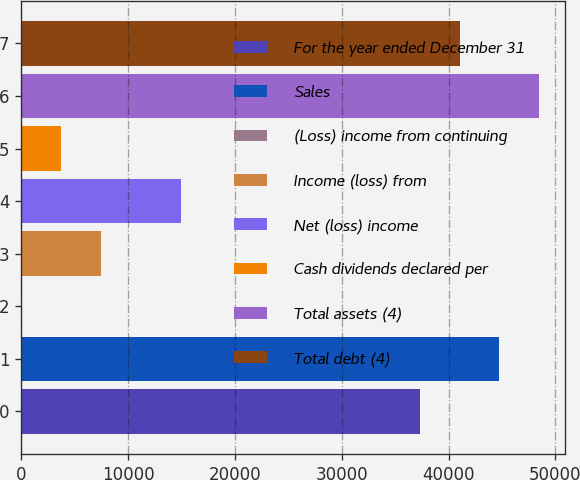Convert chart to OTSL. <chart><loc_0><loc_0><loc_500><loc_500><bar_chart><fcel>For the year ended December 31<fcel>Sales<fcel>(Loss) income from continuing<fcel>Income (loss) from<fcel>Net (loss) income<fcel>Cash dividends declared per<fcel>Total assets (4)<fcel>Total debt (4)<nl><fcel>37298<fcel>44757.6<fcel>0.21<fcel>7459.77<fcel>14919.3<fcel>3729.99<fcel>48487.3<fcel>41027.8<nl></chart> 